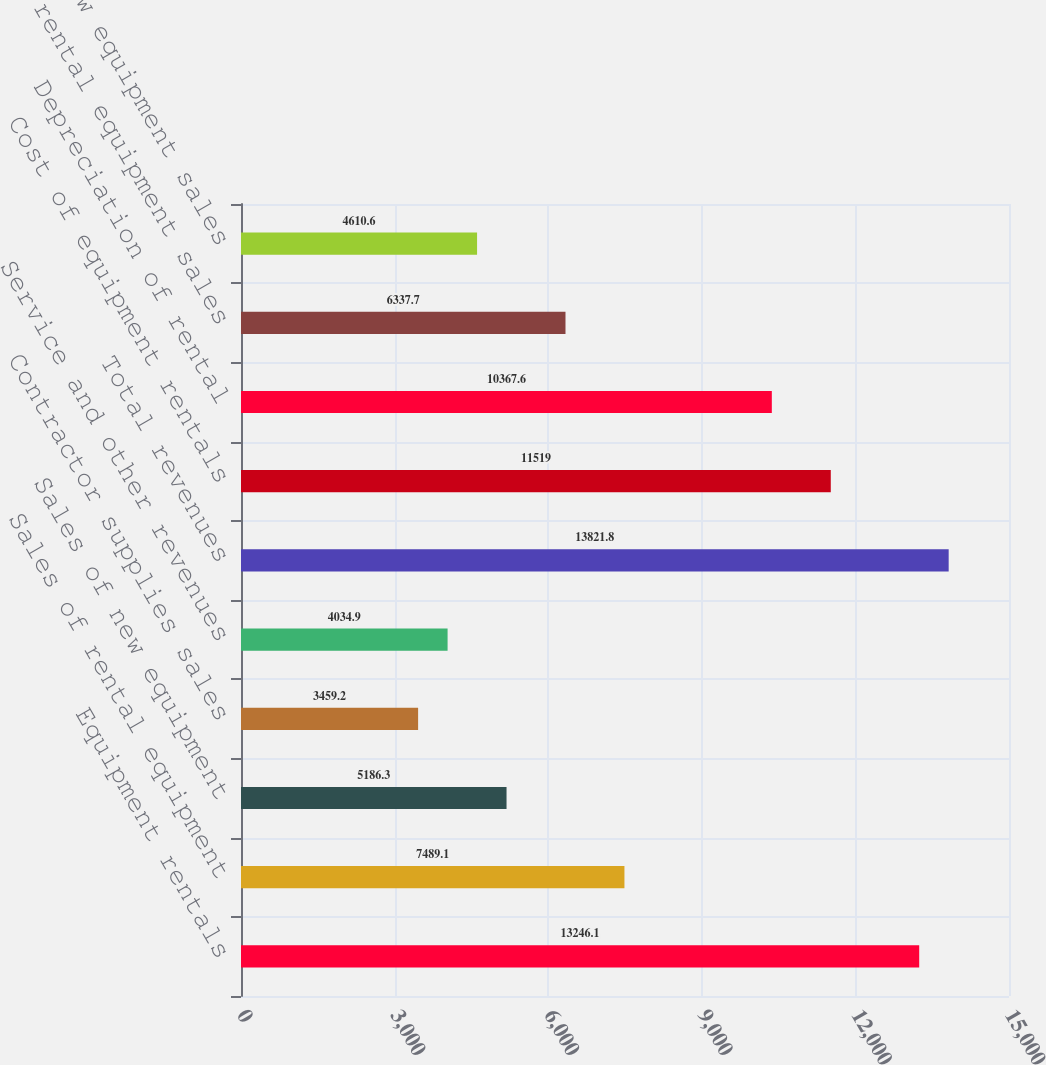<chart> <loc_0><loc_0><loc_500><loc_500><bar_chart><fcel>Equipment rentals<fcel>Sales of rental equipment<fcel>Sales of new equipment<fcel>Contractor supplies sales<fcel>Service and other revenues<fcel>Total revenues<fcel>Cost of equipment rentals<fcel>Depreciation of rental<fcel>Cost of rental equipment sales<fcel>Cost of new equipment sales<nl><fcel>13246.1<fcel>7489.1<fcel>5186.3<fcel>3459.2<fcel>4034.9<fcel>13821.8<fcel>11519<fcel>10367.6<fcel>6337.7<fcel>4610.6<nl></chart> 